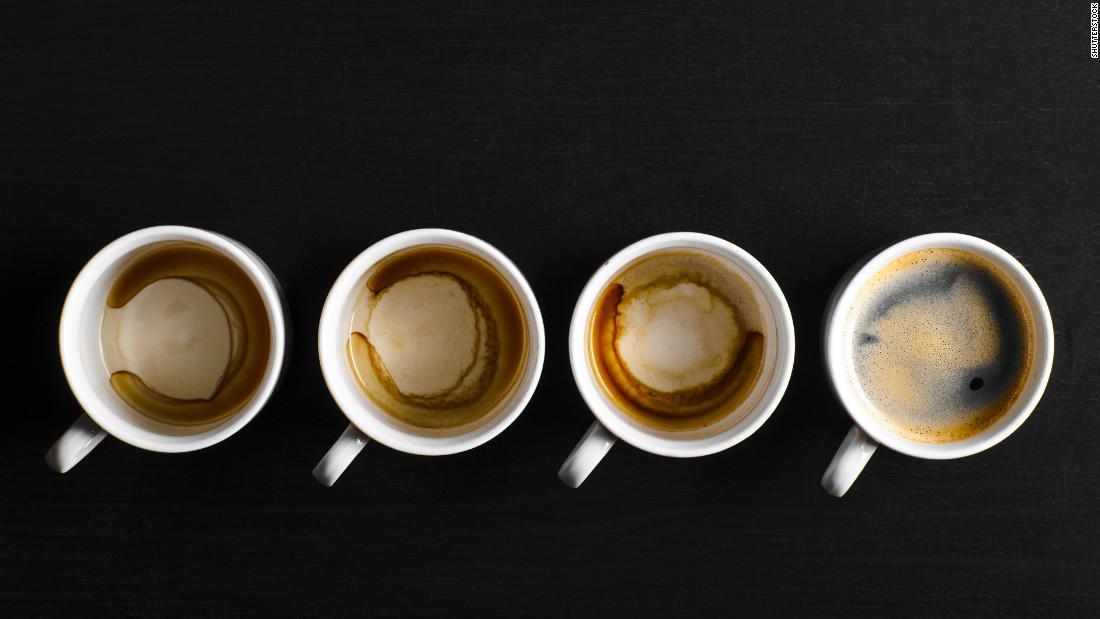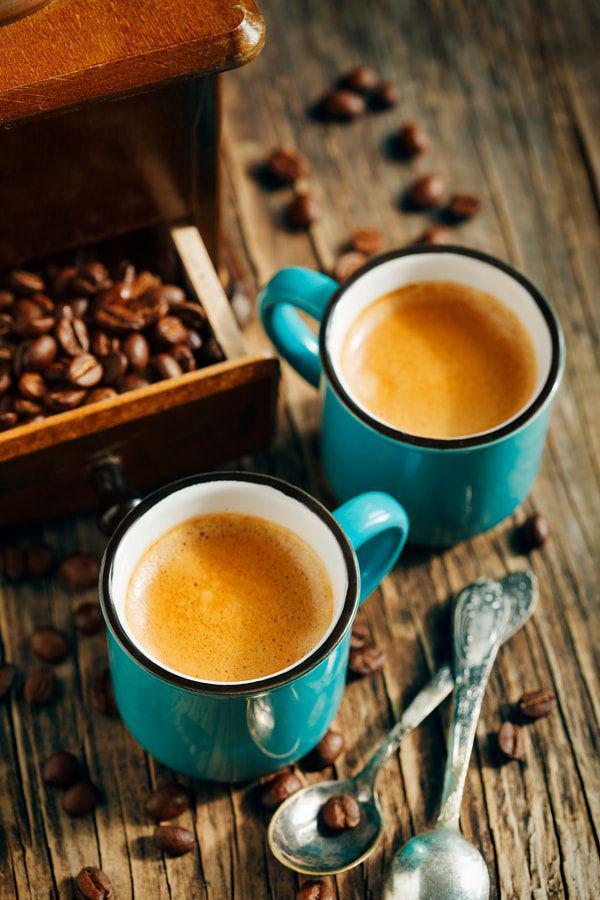The first image is the image on the left, the second image is the image on the right. For the images displayed, is the sentence "An image shows two cups of beverage, with spoons nearby." factually correct? Answer yes or no. Yes. The first image is the image on the left, the second image is the image on the right. Considering the images on both sides, is "There are at least four cups of coffee." valid? Answer yes or no. Yes. 